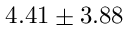<formula> <loc_0><loc_0><loc_500><loc_500>4 . 4 1 \pm 3 . 8 8</formula> 